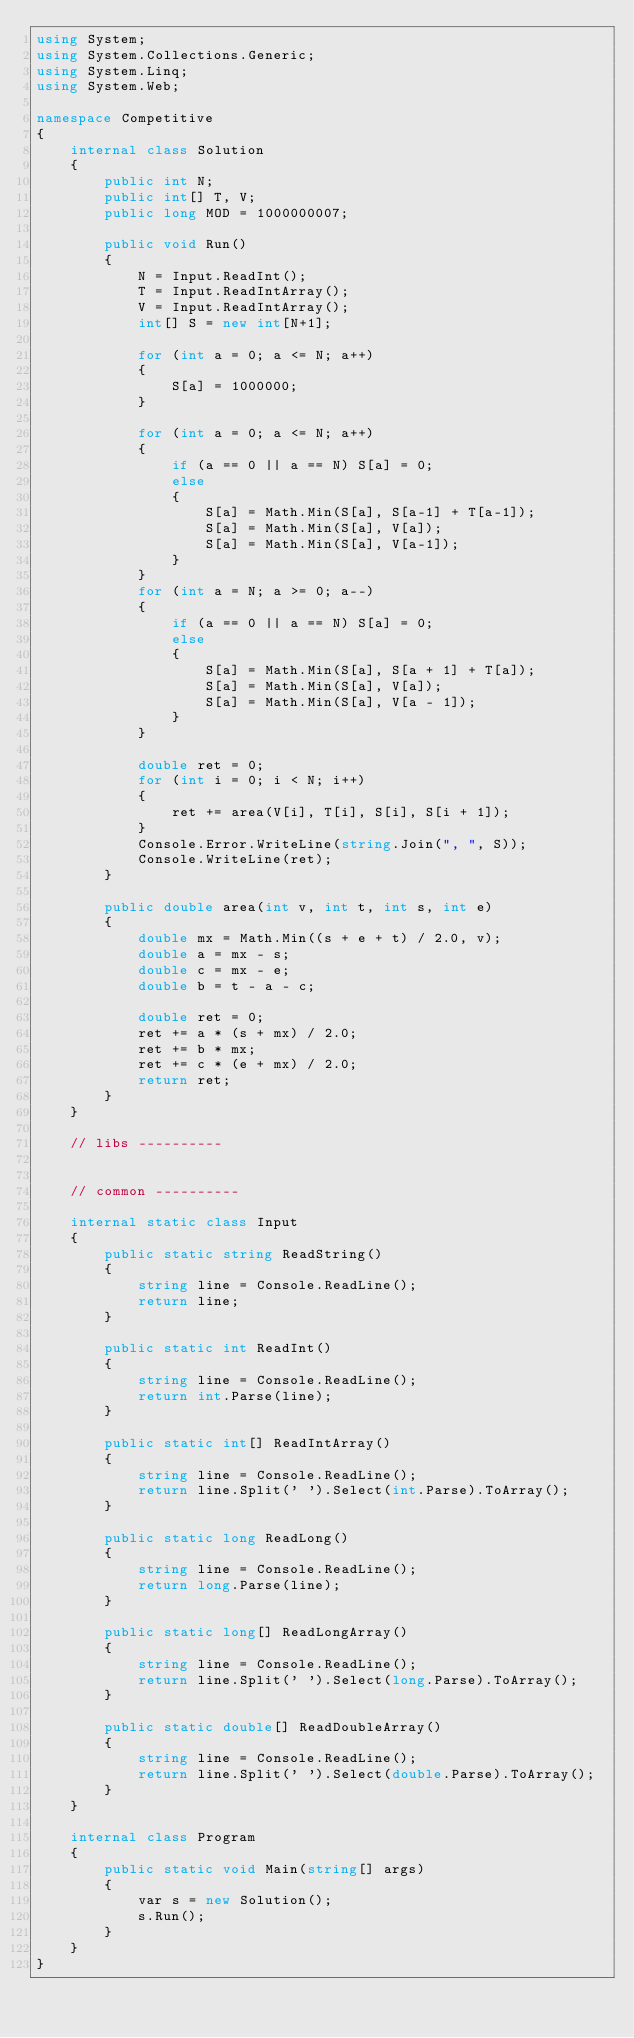<code> <loc_0><loc_0><loc_500><loc_500><_C#_>using System;
using System.Collections.Generic;
using System.Linq;
using System.Web;

namespace Competitive
{
    internal class Solution
    {
        public int N;
        public int[] T, V;
        public long MOD = 1000000007;

        public void Run()
        {
            N = Input.ReadInt();
            T = Input.ReadIntArray();
            V = Input.ReadIntArray();
            int[] S = new int[N+1];

            for (int a = 0; a <= N; a++)
            {
                S[a] = 1000000;
            }

            for (int a = 0; a <= N; a++)
            {
                if (a == 0 || a == N) S[a] = 0;
                else
                {
                    S[a] = Math.Min(S[a], S[a-1] + T[a-1]);
                    S[a] = Math.Min(S[a], V[a]);
                    S[a] = Math.Min(S[a], V[a-1]);
                }
            }
            for (int a = N; a >= 0; a--)
            {
                if (a == 0 || a == N) S[a] = 0;
                else
                {
                    S[a] = Math.Min(S[a], S[a + 1] + T[a]);
                    S[a] = Math.Min(S[a], V[a]);
                    S[a] = Math.Min(S[a], V[a - 1]);
                }
            }

            double ret = 0;
            for (int i = 0; i < N; i++)
            {
                ret += area(V[i], T[i], S[i], S[i + 1]);
            }
            Console.Error.WriteLine(string.Join(", ", S));
            Console.WriteLine(ret);
        }

        public double area(int v, int t, int s, int e)
        {
            double mx = Math.Min((s + e + t) / 2.0, v);
            double a = mx - s;
            double c = mx - e;
            double b = t - a - c;

            double ret = 0;
            ret += a * (s + mx) / 2.0;
            ret += b * mx;
            ret += c * (e + mx) / 2.0;
            return ret;
        }
    }

    // libs ----------
    

    // common ----------

    internal static class Input
    {
        public static string ReadString()
        {
            string line = Console.ReadLine();
            return line;
        }

        public static int ReadInt()
        {
            string line = Console.ReadLine();
            return int.Parse(line);
        }

        public static int[] ReadIntArray()
        {
            string line = Console.ReadLine();
            return line.Split(' ').Select(int.Parse).ToArray();            
        }

        public static long ReadLong()
        {
            string line = Console.ReadLine();
            return long.Parse(line);
        }

        public static long[] ReadLongArray()
        {
            string line = Console.ReadLine();
            return line.Split(' ').Select(long.Parse).ToArray();
        }

        public static double[] ReadDoubleArray()
        {
            string line = Console.ReadLine();
            return line.Split(' ').Select(double.Parse).ToArray();
        }
    }
    
    internal class Program
    {
        public static void Main(string[] args)
        {
            var s = new Solution();
            s.Run();
        }
    }
}</code> 